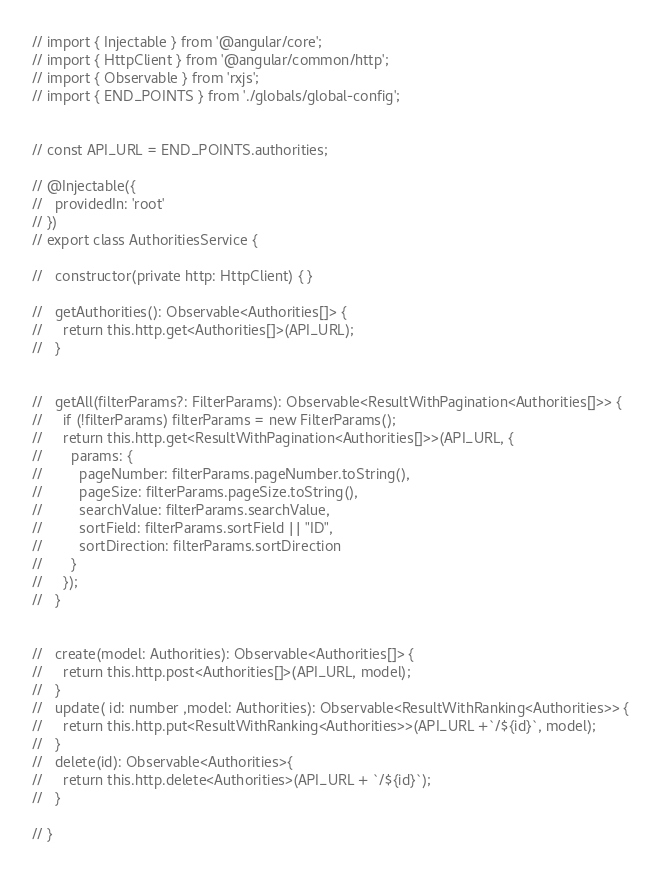Convert code to text. <code><loc_0><loc_0><loc_500><loc_500><_TypeScript_>// import { Injectable } from '@angular/core';
// import { HttpClient } from '@angular/common/http';
// import { Observable } from 'rxjs';
// import { END_POINTS } from './globals/global-config';


// const API_URL = END_POINTS.authorities;

// @Injectable({
//   providedIn: 'root'
// })
// export class AuthoritiesService {

//   constructor(private http: HttpClient) { }

//   getAuthorities(): Observable<Authorities[]> {
//     return this.http.get<Authorities[]>(API_URL);
//   }

  
//   getAll(filterParams?: FilterParams): Observable<ResultWithPagination<Authorities[]>> {
//     if (!filterParams) filterParams = new FilterParams();
//     return this.http.get<ResultWithPagination<Authorities[]>>(API_URL, {
//       params: {
//         pageNumber: filterParams.pageNumber.toString(),
//         pageSize: filterParams.pageSize.toString(),
//         searchValue: filterParams.searchValue,
//         sortField: filterParams.sortField || "ID",
//         sortDirection: filterParams.sortDirection
//       }
//     });
//   }
  

//   create(model: Authorities): Observable<Authorities[]> {
//     return this.http.post<Authorities[]>(API_URL, model);
//   }
//   update( id: number ,model: Authorities): Observable<ResultWithRanking<Authorities>> {
//     return this.http.put<ResultWithRanking<Authorities>>(API_URL +`/${id}`, model);
//   }
//   delete(id): Observable<Authorities>{
//     return this.http.delete<Authorities>(API_URL + `/${id}`);
//   }

// }
</code> 